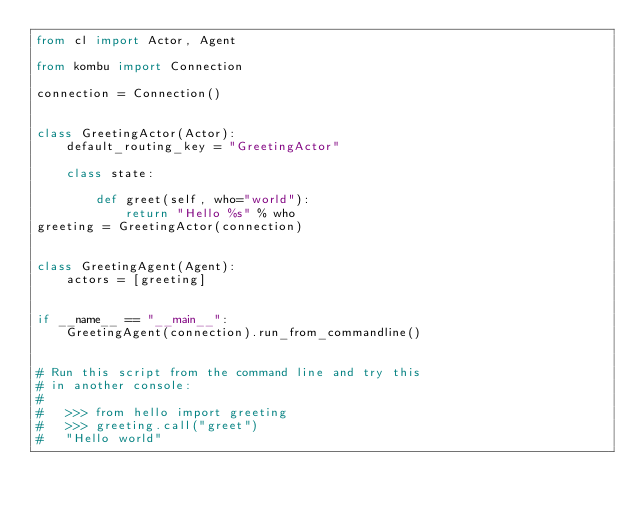<code> <loc_0><loc_0><loc_500><loc_500><_Python_>from cl import Actor, Agent

from kombu import Connection

connection = Connection()


class GreetingActor(Actor):
    default_routing_key = "GreetingActor"

    class state:

        def greet(self, who="world"):
            return "Hello %s" % who
greeting = GreetingActor(connection)


class GreetingAgent(Agent):
    actors = [greeting]


if __name__ == "__main__":
    GreetingAgent(connection).run_from_commandline()


# Run this script from the command line and try this
# in another console:
#
#   >>> from hello import greeting
#   >>> greeting.call("greet")
#   "Hello world"
</code> 